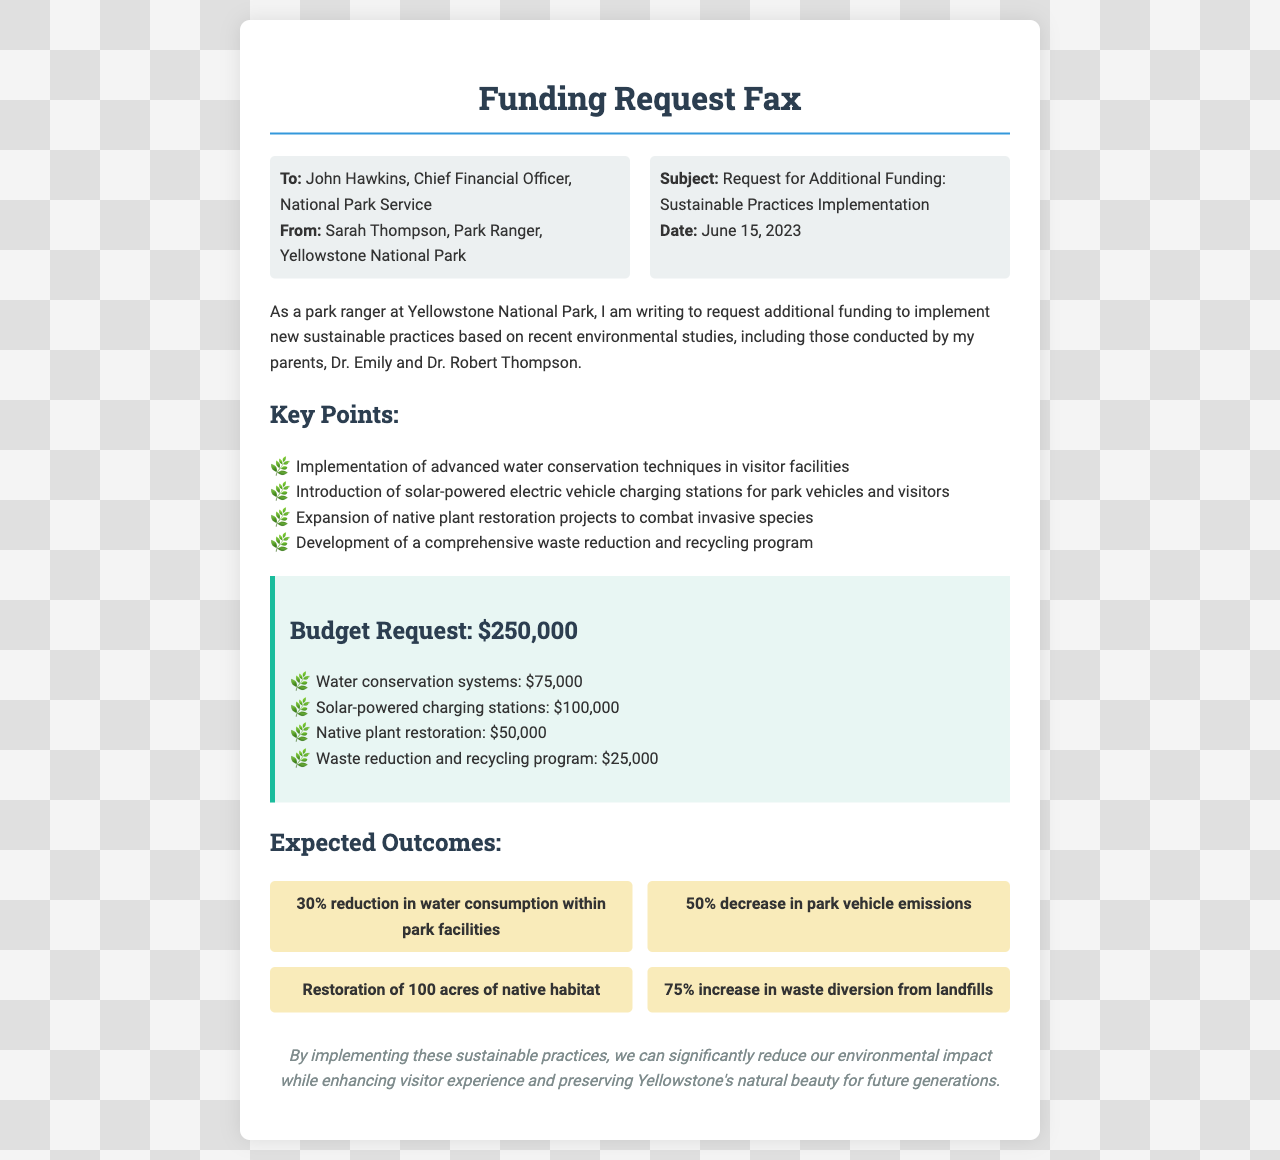what is the total budget request? The total budget request is explicitly stated in the document as $250,000.
Answer: $250,000 who is the sender of the fax? The sender is identified at the beginning of the document as Sarah Thompson, Park Ranger, Yellowstone National Park.
Answer: Sarah Thompson what sustainable practice involves solar energy? The document mentions the introduction of solar-powered electric vehicle charging stations for park vehicles and visitors.
Answer: Solar-powered charging stations how many acres of native habitat are targeted for restoration? The expected outcome states a goal of restoring 100 acres of native habitat.
Answer: 100 acres what is one of the expected outcomes related to waste? The document lists a 75% increase in waste diversion from landfills as one of the expected outcomes.
Answer: 75% increase who are the parents of the sender? The sender's parents, mentioned in the document, are Dr. Emily and Dr. Robert Thompson, noted for conducting environmental studies.
Answer: Dr. Emily and Dr. Robert Thompson what is one of the advanced techniques proposed for visitor facilities? The document specifies the implementation of advanced water conservation techniques in visitor facilities.
Answer: Water conservation techniques when was the funding request faxed? The document clearly states that the date of the fax is June 15, 2023.
Answer: June 15, 2023 